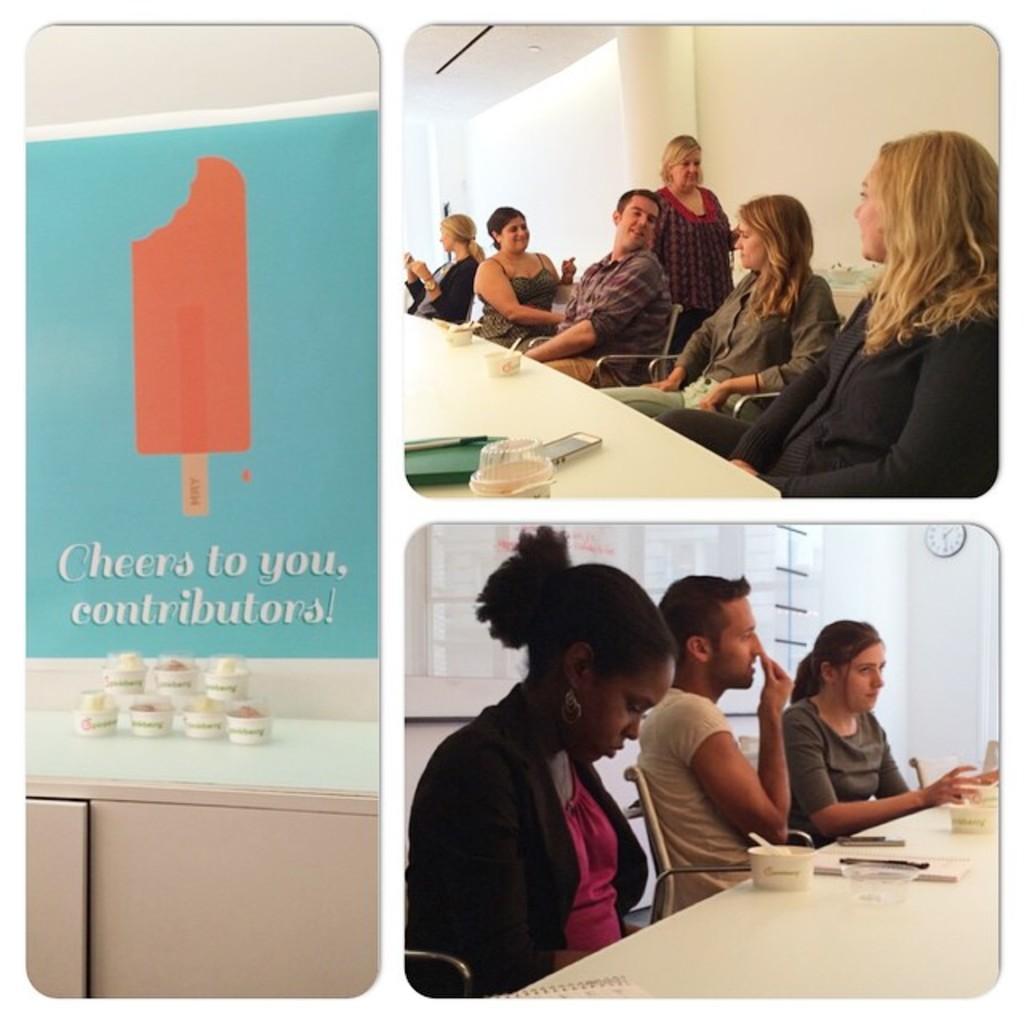In one or two sentences, can you explain what this image depicts? In this image there are few people sitting on the chair. On the table there is a bowl,book and a mobile. 